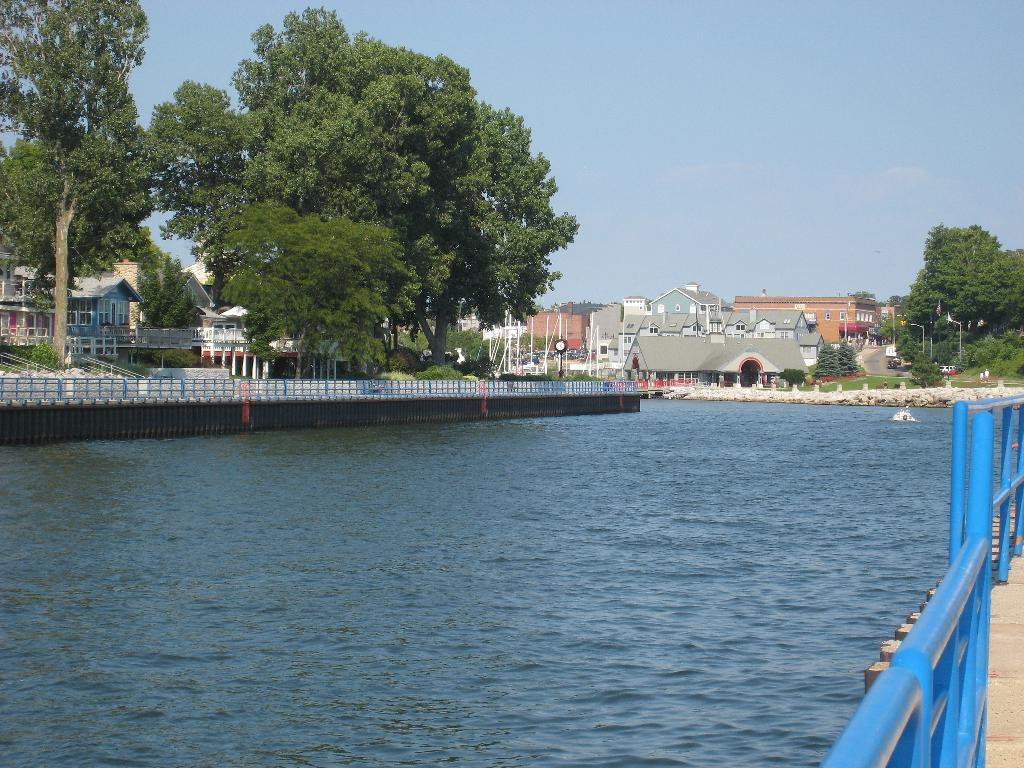What is the primary element in the image? The image consists of water. What color is the railing on the right side of the image? The railing is in blue color on the right side of the image. What can be seen in the background of the image? There are buildings and many trees visible in the background of the image. What is visible at the top of the image? The sky is visible at the top of the image. What type of meat is floating in the water in the image? There is no meat present in the image; it consists of water with a blue railing and background elements. 